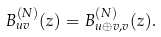<formula> <loc_0><loc_0><loc_500><loc_500>B _ { u v } ^ { ( N ) } ( z ) = B _ { u \oplus v , v } ^ { ( N ) } ( z ) .</formula> 